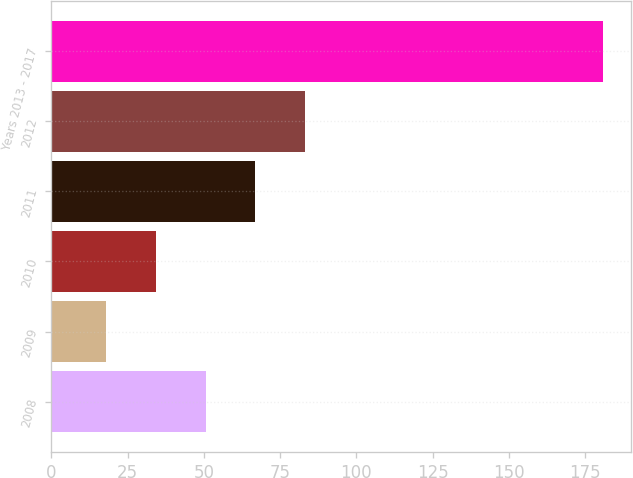Convert chart. <chart><loc_0><loc_0><loc_500><loc_500><bar_chart><fcel>2008<fcel>2009<fcel>2010<fcel>2011<fcel>2012<fcel>Years 2013 - 2017<nl><fcel>50.6<fcel>18<fcel>34.3<fcel>66.9<fcel>83.2<fcel>181<nl></chart> 